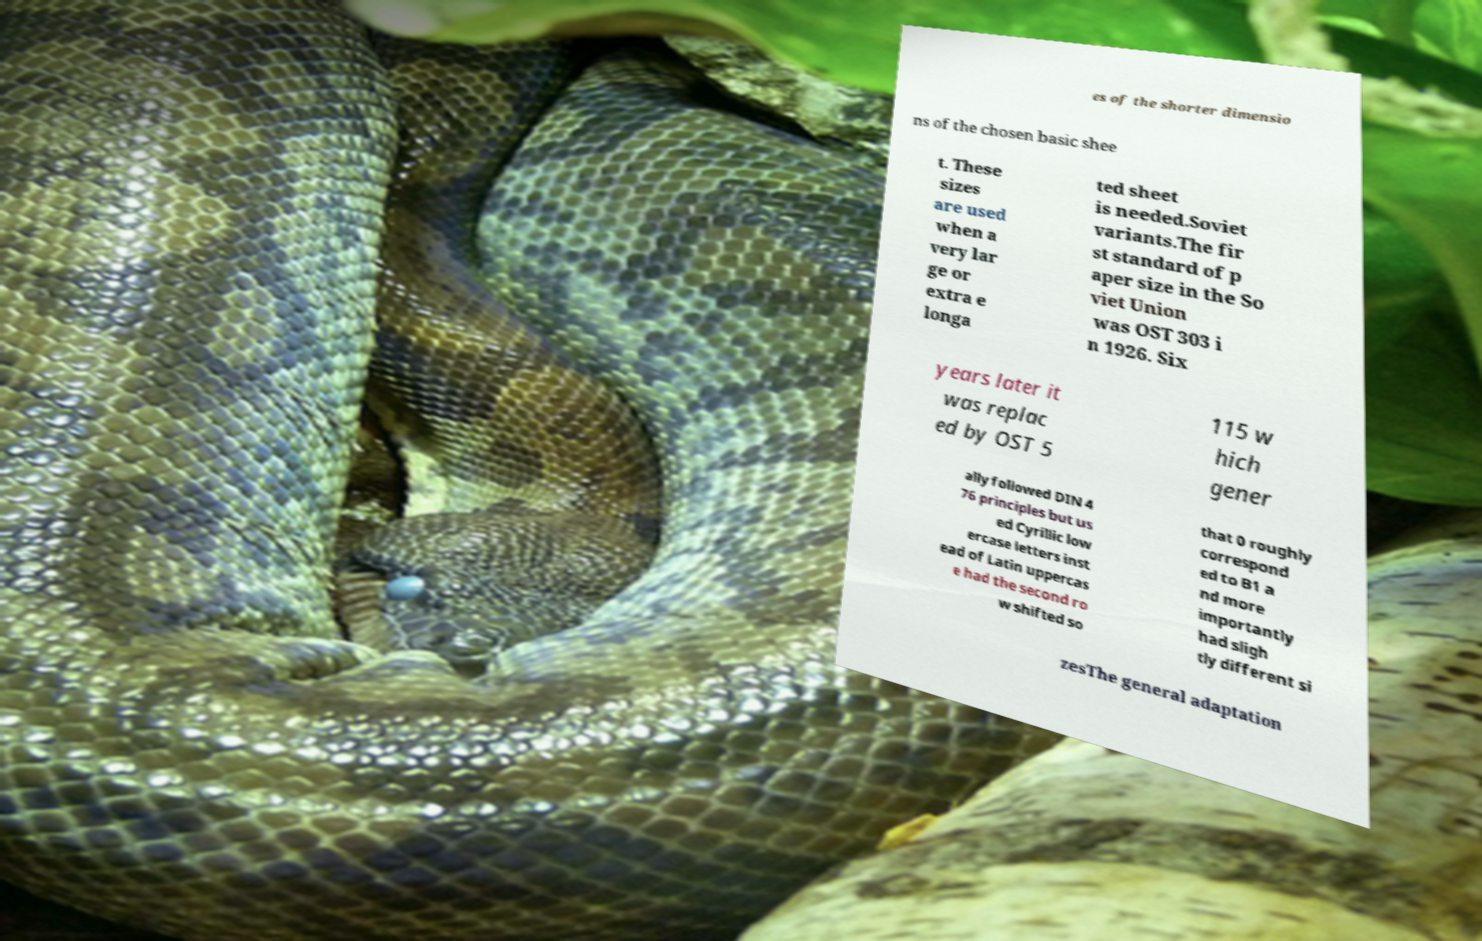For documentation purposes, I need the text within this image transcribed. Could you provide that? es of the shorter dimensio ns of the chosen basic shee t. These sizes are used when a very lar ge or extra e longa ted sheet is needed.Soviet variants.The fir st standard of p aper size in the So viet Union was OST 303 i n 1926. Six years later it was replac ed by OST 5 115 w hich gener ally followed DIN 4 76 principles but us ed Cyrillic low ercase letters inst ead of Latin uppercas e had the second ro w shifted so that 0 roughly correspond ed to B1 a nd more importantly had sligh tly different si zesThe general adaptation 